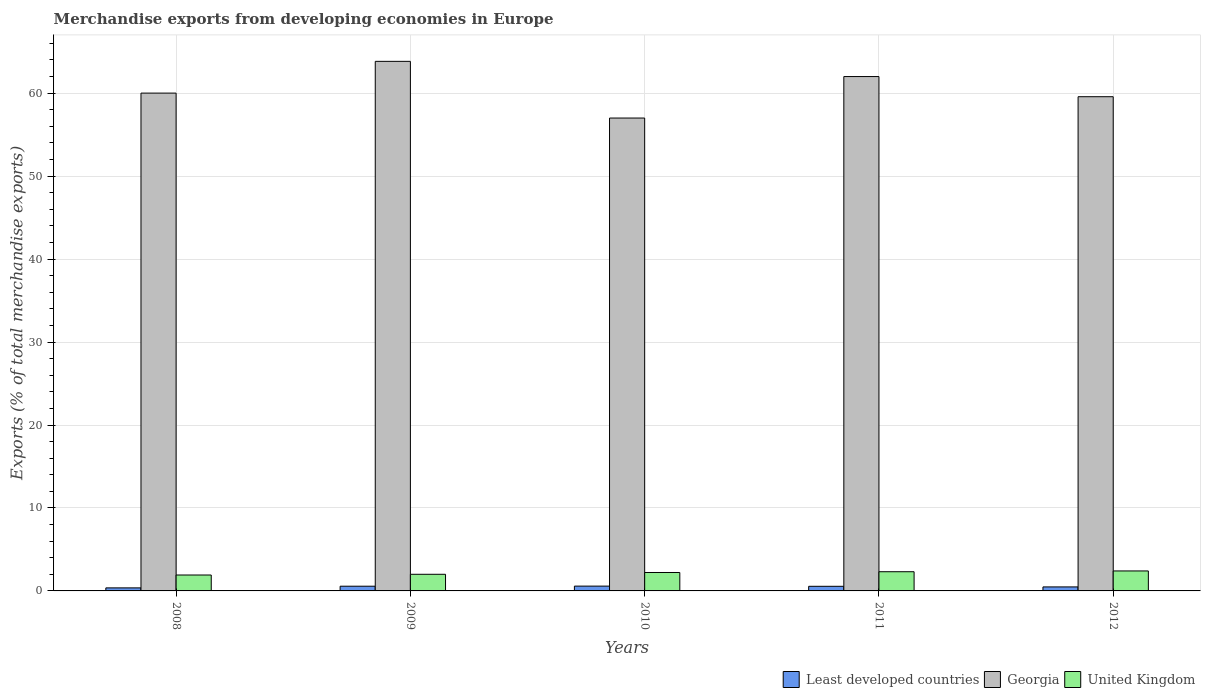Are the number of bars on each tick of the X-axis equal?
Ensure brevity in your answer.  Yes. How many bars are there on the 3rd tick from the left?
Offer a terse response. 3. What is the label of the 4th group of bars from the left?
Offer a terse response. 2011. What is the percentage of total merchandise exports in Georgia in 2012?
Your answer should be very brief. 59.57. Across all years, what is the maximum percentage of total merchandise exports in Georgia?
Your answer should be compact. 63.84. Across all years, what is the minimum percentage of total merchandise exports in Least developed countries?
Provide a short and direct response. 0.37. In which year was the percentage of total merchandise exports in Georgia maximum?
Provide a short and direct response. 2009. In which year was the percentage of total merchandise exports in Least developed countries minimum?
Offer a very short reply. 2008. What is the total percentage of total merchandise exports in Georgia in the graph?
Make the answer very short. 302.42. What is the difference between the percentage of total merchandise exports in Georgia in 2010 and that in 2011?
Your response must be concise. -5. What is the difference between the percentage of total merchandise exports in United Kingdom in 2008 and the percentage of total merchandise exports in Least developed countries in 2010?
Provide a short and direct response. 1.34. What is the average percentage of total merchandise exports in United Kingdom per year?
Offer a very short reply. 2.17. In the year 2008, what is the difference between the percentage of total merchandise exports in United Kingdom and percentage of total merchandise exports in Least developed countries?
Give a very brief answer. 1.55. What is the ratio of the percentage of total merchandise exports in Georgia in 2010 to that in 2012?
Give a very brief answer. 0.96. Is the percentage of total merchandise exports in Least developed countries in 2009 less than that in 2010?
Make the answer very short. Yes. What is the difference between the highest and the second highest percentage of total merchandise exports in United Kingdom?
Your response must be concise. 0.1. What is the difference between the highest and the lowest percentage of total merchandise exports in United Kingdom?
Your response must be concise. 0.49. What does the 1st bar from the left in 2009 represents?
Provide a succinct answer. Least developed countries. Are all the bars in the graph horizontal?
Offer a very short reply. No. What is the difference between two consecutive major ticks on the Y-axis?
Offer a very short reply. 10. Where does the legend appear in the graph?
Your response must be concise. Bottom right. How are the legend labels stacked?
Ensure brevity in your answer.  Horizontal. What is the title of the graph?
Provide a short and direct response. Merchandise exports from developing economies in Europe. What is the label or title of the Y-axis?
Your answer should be compact. Exports (% of total merchandise exports). What is the Exports (% of total merchandise exports) of Least developed countries in 2008?
Provide a succinct answer. 0.37. What is the Exports (% of total merchandise exports) in Georgia in 2008?
Your answer should be very brief. 60.01. What is the Exports (% of total merchandise exports) in United Kingdom in 2008?
Offer a very short reply. 1.92. What is the Exports (% of total merchandise exports) of Least developed countries in 2009?
Your answer should be compact. 0.57. What is the Exports (% of total merchandise exports) of Georgia in 2009?
Keep it short and to the point. 63.84. What is the Exports (% of total merchandise exports) in United Kingdom in 2009?
Your response must be concise. 2. What is the Exports (% of total merchandise exports) of Least developed countries in 2010?
Provide a succinct answer. 0.58. What is the Exports (% of total merchandise exports) of Georgia in 2010?
Ensure brevity in your answer.  57. What is the Exports (% of total merchandise exports) of United Kingdom in 2010?
Your answer should be very brief. 2.22. What is the Exports (% of total merchandise exports) of Least developed countries in 2011?
Ensure brevity in your answer.  0.56. What is the Exports (% of total merchandise exports) of Georgia in 2011?
Make the answer very short. 62. What is the Exports (% of total merchandise exports) in United Kingdom in 2011?
Offer a terse response. 2.31. What is the Exports (% of total merchandise exports) in Least developed countries in 2012?
Make the answer very short. 0.48. What is the Exports (% of total merchandise exports) in Georgia in 2012?
Your response must be concise. 59.57. What is the Exports (% of total merchandise exports) of United Kingdom in 2012?
Your answer should be compact. 2.41. Across all years, what is the maximum Exports (% of total merchandise exports) in Least developed countries?
Provide a succinct answer. 0.58. Across all years, what is the maximum Exports (% of total merchandise exports) in Georgia?
Your answer should be compact. 63.84. Across all years, what is the maximum Exports (% of total merchandise exports) of United Kingdom?
Provide a succinct answer. 2.41. Across all years, what is the minimum Exports (% of total merchandise exports) of Least developed countries?
Offer a terse response. 0.37. Across all years, what is the minimum Exports (% of total merchandise exports) of Georgia?
Ensure brevity in your answer.  57. Across all years, what is the minimum Exports (% of total merchandise exports) of United Kingdom?
Your answer should be compact. 1.92. What is the total Exports (% of total merchandise exports) in Least developed countries in the graph?
Offer a very short reply. 2.55. What is the total Exports (% of total merchandise exports) of Georgia in the graph?
Offer a very short reply. 302.42. What is the total Exports (% of total merchandise exports) in United Kingdom in the graph?
Your answer should be very brief. 10.87. What is the difference between the Exports (% of total merchandise exports) of Least developed countries in 2008 and that in 2009?
Your response must be concise. -0.2. What is the difference between the Exports (% of total merchandise exports) of Georgia in 2008 and that in 2009?
Make the answer very short. -3.83. What is the difference between the Exports (% of total merchandise exports) of United Kingdom in 2008 and that in 2009?
Give a very brief answer. -0.09. What is the difference between the Exports (% of total merchandise exports) in Least developed countries in 2008 and that in 2010?
Ensure brevity in your answer.  -0.21. What is the difference between the Exports (% of total merchandise exports) of Georgia in 2008 and that in 2010?
Provide a short and direct response. 3.01. What is the difference between the Exports (% of total merchandise exports) in United Kingdom in 2008 and that in 2010?
Your response must be concise. -0.3. What is the difference between the Exports (% of total merchandise exports) of Least developed countries in 2008 and that in 2011?
Make the answer very short. -0.19. What is the difference between the Exports (% of total merchandise exports) in Georgia in 2008 and that in 2011?
Make the answer very short. -1.99. What is the difference between the Exports (% of total merchandise exports) in United Kingdom in 2008 and that in 2011?
Keep it short and to the point. -0.39. What is the difference between the Exports (% of total merchandise exports) in Least developed countries in 2008 and that in 2012?
Provide a succinct answer. -0.12. What is the difference between the Exports (% of total merchandise exports) in Georgia in 2008 and that in 2012?
Offer a very short reply. 0.44. What is the difference between the Exports (% of total merchandise exports) in United Kingdom in 2008 and that in 2012?
Make the answer very short. -0.49. What is the difference between the Exports (% of total merchandise exports) in Least developed countries in 2009 and that in 2010?
Keep it short and to the point. -0.01. What is the difference between the Exports (% of total merchandise exports) of Georgia in 2009 and that in 2010?
Provide a short and direct response. 6.83. What is the difference between the Exports (% of total merchandise exports) in United Kingdom in 2009 and that in 2010?
Keep it short and to the point. -0.22. What is the difference between the Exports (% of total merchandise exports) in Least developed countries in 2009 and that in 2011?
Your answer should be very brief. 0.01. What is the difference between the Exports (% of total merchandise exports) of Georgia in 2009 and that in 2011?
Give a very brief answer. 1.83. What is the difference between the Exports (% of total merchandise exports) in United Kingdom in 2009 and that in 2011?
Ensure brevity in your answer.  -0.31. What is the difference between the Exports (% of total merchandise exports) in Least developed countries in 2009 and that in 2012?
Provide a short and direct response. 0.09. What is the difference between the Exports (% of total merchandise exports) in Georgia in 2009 and that in 2012?
Make the answer very short. 4.26. What is the difference between the Exports (% of total merchandise exports) of United Kingdom in 2009 and that in 2012?
Offer a very short reply. -0.4. What is the difference between the Exports (% of total merchandise exports) of Least developed countries in 2010 and that in 2011?
Your response must be concise. 0.02. What is the difference between the Exports (% of total merchandise exports) in Georgia in 2010 and that in 2011?
Give a very brief answer. -5. What is the difference between the Exports (% of total merchandise exports) in United Kingdom in 2010 and that in 2011?
Provide a short and direct response. -0.09. What is the difference between the Exports (% of total merchandise exports) in Least developed countries in 2010 and that in 2012?
Ensure brevity in your answer.  0.1. What is the difference between the Exports (% of total merchandise exports) of Georgia in 2010 and that in 2012?
Ensure brevity in your answer.  -2.57. What is the difference between the Exports (% of total merchandise exports) in United Kingdom in 2010 and that in 2012?
Offer a terse response. -0.19. What is the difference between the Exports (% of total merchandise exports) of Least developed countries in 2011 and that in 2012?
Keep it short and to the point. 0.07. What is the difference between the Exports (% of total merchandise exports) in Georgia in 2011 and that in 2012?
Keep it short and to the point. 2.43. What is the difference between the Exports (% of total merchandise exports) of United Kingdom in 2011 and that in 2012?
Give a very brief answer. -0.1. What is the difference between the Exports (% of total merchandise exports) in Least developed countries in 2008 and the Exports (% of total merchandise exports) in Georgia in 2009?
Give a very brief answer. -63.47. What is the difference between the Exports (% of total merchandise exports) of Least developed countries in 2008 and the Exports (% of total merchandise exports) of United Kingdom in 2009?
Keep it short and to the point. -1.64. What is the difference between the Exports (% of total merchandise exports) in Georgia in 2008 and the Exports (% of total merchandise exports) in United Kingdom in 2009?
Your answer should be compact. 58. What is the difference between the Exports (% of total merchandise exports) in Least developed countries in 2008 and the Exports (% of total merchandise exports) in Georgia in 2010?
Your answer should be compact. -56.64. What is the difference between the Exports (% of total merchandise exports) of Least developed countries in 2008 and the Exports (% of total merchandise exports) of United Kingdom in 2010?
Make the answer very short. -1.85. What is the difference between the Exports (% of total merchandise exports) in Georgia in 2008 and the Exports (% of total merchandise exports) in United Kingdom in 2010?
Make the answer very short. 57.79. What is the difference between the Exports (% of total merchandise exports) of Least developed countries in 2008 and the Exports (% of total merchandise exports) of Georgia in 2011?
Your answer should be compact. -61.64. What is the difference between the Exports (% of total merchandise exports) of Least developed countries in 2008 and the Exports (% of total merchandise exports) of United Kingdom in 2011?
Your answer should be compact. -1.95. What is the difference between the Exports (% of total merchandise exports) in Georgia in 2008 and the Exports (% of total merchandise exports) in United Kingdom in 2011?
Make the answer very short. 57.7. What is the difference between the Exports (% of total merchandise exports) of Least developed countries in 2008 and the Exports (% of total merchandise exports) of Georgia in 2012?
Ensure brevity in your answer.  -59.21. What is the difference between the Exports (% of total merchandise exports) in Least developed countries in 2008 and the Exports (% of total merchandise exports) in United Kingdom in 2012?
Give a very brief answer. -2.04. What is the difference between the Exports (% of total merchandise exports) of Georgia in 2008 and the Exports (% of total merchandise exports) of United Kingdom in 2012?
Provide a succinct answer. 57.6. What is the difference between the Exports (% of total merchandise exports) in Least developed countries in 2009 and the Exports (% of total merchandise exports) in Georgia in 2010?
Your answer should be very brief. -56.43. What is the difference between the Exports (% of total merchandise exports) of Least developed countries in 2009 and the Exports (% of total merchandise exports) of United Kingdom in 2010?
Give a very brief answer. -1.65. What is the difference between the Exports (% of total merchandise exports) in Georgia in 2009 and the Exports (% of total merchandise exports) in United Kingdom in 2010?
Your answer should be very brief. 61.61. What is the difference between the Exports (% of total merchandise exports) in Least developed countries in 2009 and the Exports (% of total merchandise exports) in Georgia in 2011?
Provide a succinct answer. -61.43. What is the difference between the Exports (% of total merchandise exports) in Least developed countries in 2009 and the Exports (% of total merchandise exports) in United Kingdom in 2011?
Keep it short and to the point. -1.74. What is the difference between the Exports (% of total merchandise exports) in Georgia in 2009 and the Exports (% of total merchandise exports) in United Kingdom in 2011?
Ensure brevity in your answer.  61.52. What is the difference between the Exports (% of total merchandise exports) of Least developed countries in 2009 and the Exports (% of total merchandise exports) of Georgia in 2012?
Offer a terse response. -59. What is the difference between the Exports (% of total merchandise exports) in Least developed countries in 2009 and the Exports (% of total merchandise exports) in United Kingdom in 2012?
Give a very brief answer. -1.84. What is the difference between the Exports (% of total merchandise exports) in Georgia in 2009 and the Exports (% of total merchandise exports) in United Kingdom in 2012?
Your answer should be compact. 61.43. What is the difference between the Exports (% of total merchandise exports) in Least developed countries in 2010 and the Exports (% of total merchandise exports) in Georgia in 2011?
Keep it short and to the point. -61.42. What is the difference between the Exports (% of total merchandise exports) in Least developed countries in 2010 and the Exports (% of total merchandise exports) in United Kingdom in 2011?
Make the answer very short. -1.73. What is the difference between the Exports (% of total merchandise exports) in Georgia in 2010 and the Exports (% of total merchandise exports) in United Kingdom in 2011?
Keep it short and to the point. 54.69. What is the difference between the Exports (% of total merchandise exports) of Least developed countries in 2010 and the Exports (% of total merchandise exports) of Georgia in 2012?
Offer a terse response. -58.99. What is the difference between the Exports (% of total merchandise exports) in Least developed countries in 2010 and the Exports (% of total merchandise exports) in United Kingdom in 2012?
Provide a short and direct response. -1.83. What is the difference between the Exports (% of total merchandise exports) in Georgia in 2010 and the Exports (% of total merchandise exports) in United Kingdom in 2012?
Give a very brief answer. 54.59. What is the difference between the Exports (% of total merchandise exports) of Least developed countries in 2011 and the Exports (% of total merchandise exports) of Georgia in 2012?
Keep it short and to the point. -59.02. What is the difference between the Exports (% of total merchandise exports) in Least developed countries in 2011 and the Exports (% of total merchandise exports) in United Kingdom in 2012?
Give a very brief answer. -1.85. What is the difference between the Exports (% of total merchandise exports) in Georgia in 2011 and the Exports (% of total merchandise exports) in United Kingdom in 2012?
Keep it short and to the point. 59.6. What is the average Exports (% of total merchandise exports) of Least developed countries per year?
Keep it short and to the point. 0.51. What is the average Exports (% of total merchandise exports) in Georgia per year?
Ensure brevity in your answer.  60.48. What is the average Exports (% of total merchandise exports) of United Kingdom per year?
Offer a terse response. 2.17. In the year 2008, what is the difference between the Exports (% of total merchandise exports) in Least developed countries and Exports (% of total merchandise exports) in Georgia?
Give a very brief answer. -59.64. In the year 2008, what is the difference between the Exports (% of total merchandise exports) in Least developed countries and Exports (% of total merchandise exports) in United Kingdom?
Keep it short and to the point. -1.55. In the year 2008, what is the difference between the Exports (% of total merchandise exports) of Georgia and Exports (% of total merchandise exports) of United Kingdom?
Give a very brief answer. 58.09. In the year 2009, what is the difference between the Exports (% of total merchandise exports) in Least developed countries and Exports (% of total merchandise exports) in Georgia?
Make the answer very short. -63.27. In the year 2009, what is the difference between the Exports (% of total merchandise exports) in Least developed countries and Exports (% of total merchandise exports) in United Kingdom?
Make the answer very short. -1.44. In the year 2009, what is the difference between the Exports (% of total merchandise exports) in Georgia and Exports (% of total merchandise exports) in United Kingdom?
Give a very brief answer. 61.83. In the year 2010, what is the difference between the Exports (% of total merchandise exports) in Least developed countries and Exports (% of total merchandise exports) in Georgia?
Provide a succinct answer. -56.42. In the year 2010, what is the difference between the Exports (% of total merchandise exports) in Least developed countries and Exports (% of total merchandise exports) in United Kingdom?
Ensure brevity in your answer.  -1.64. In the year 2010, what is the difference between the Exports (% of total merchandise exports) in Georgia and Exports (% of total merchandise exports) in United Kingdom?
Keep it short and to the point. 54.78. In the year 2011, what is the difference between the Exports (% of total merchandise exports) of Least developed countries and Exports (% of total merchandise exports) of Georgia?
Ensure brevity in your answer.  -61.45. In the year 2011, what is the difference between the Exports (% of total merchandise exports) of Least developed countries and Exports (% of total merchandise exports) of United Kingdom?
Ensure brevity in your answer.  -1.76. In the year 2011, what is the difference between the Exports (% of total merchandise exports) in Georgia and Exports (% of total merchandise exports) in United Kingdom?
Offer a very short reply. 59.69. In the year 2012, what is the difference between the Exports (% of total merchandise exports) of Least developed countries and Exports (% of total merchandise exports) of Georgia?
Make the answer very short. -59.09. In the year 2012, what is the difference between the Exports (% of total merchandise exports) in Least developed countries and Exports (% of total merchandise exports) in United Kingdom?
Your answer should be compact. -1.92. In the year 2012, what is the difference between the Exports (% of total merchandise exports) in Georgia and Exports (% of total merchandise exports) in United Kingdom?
Your answer should be very brief. 57.16. What is the ratio of the Exports (% of total merchandise exports) of Least developed countries in 2008 to that in 2009?
Ensure brevity in your answer.  0.64. What is the ratio of the Exports (% of total merchandise exports) of Georgia in 2008 to that in 2009?
Offer a terse response. 0.94. What is the ratio of the Exports (% of total merchandise exports) in United Kingdom in 2008 to that in 2009?
Ensure brevity in your answer.  0.96. What is the ratio of the Exports (% of total merchandise exports) of Least developed countries in 2008 to that in 2010?
Give a very brief answer. 0.63. What is the ratio of the Exports (% of total merchandise exports) of Georgia in 2008 to that in 2010?
Offer a terse response. 1.05. What is the ratio of the Exports (% of total merchandise exports) of United Kingdom in 2008 to that in 2010?
Provide a short and direct response. 0.86. What is the ratio of the Exports (% of total merchandise exports) in Least developed countries in 2008 to that in 2011?
Your answer should be compact. 0.66. What is the ratio of the Exports (% of total merchandise exports) of Georgia in 2008 to that in 2011?
Provide a short and direct response. 0.97. What is the ratio of the Exports (% of total merchandise exports) of United Kingdom in 2008 to that in 2011?
Your response must be concise. 0.83. What is the ratio of the Exports (% of total merchandise exports) of Least developed countries in 2008 to that in 2012?
Offer a very short reply. 0.76. What is the ratio of the Exports (% of total merchandise exports) in Georgia in 2008 to that in 2012?
Ensure brevity in your answer.  1.01. What is the ratio of the Exports (% of total merchandise exports) of United Kingdom in 2008 to that in 2012?
Keep it short and to the point. 0.8. What is the ratio of the Exports (% of total merchandise exports) in Least developed countries in 2009 to that in 2010?
Offer a very short reply. 0.98. What is the ratio of the Exports (% of total merchandise exports) in Georgia in 2009 to that in 2010?
Provide a succinct answer. 1.12. What is the ratio of the Exports (% of total merchandise exports) of United Kingdom in 2009 to that in 2010?
Provide a short and direct response. 0.9. What is the ratio of the Exports (% of total merchandise exports) in Least developed countries in 2009 to that in 2011?
Give a very brief answer. 1.02. What is the ratio of the Exports (% of total merchandise exports) in Georgia in 2009 to that in 2011?
Provide a short and direct response. 1.03. What is the ratio of the Exports (% of total merchandise exports) of United Kingdom in 2009 to that in 2011?
Ensure brevity in your answer.  0.87. What is the ratio of the Exports (% of total merchandise exports) in Least developed countries in 2009 to that in 2012?
Your answer should be very brief. 1.18. What is the ratio of the Exports (% of total merchandise exports) in Georgia in 2009 to that in 2012?
Ensure brevity in your answer.  1.07. What is the ratio of the Exports (% of total merchandise exports) in United Kingdom in 2009 to that in 2012?
Give a very brief answer. 0.83. What is the ratio of the Exports (% of total merchandise exports) of Least developed countries in 2010 to that in 2011?
Offer a terse response. 1.04. What is the ratio of the Exports (% of total merchandise exports) in Georgia in 2010 to that in 2011?
Make the answer very short. 0.92. What is the ratio of the Exports (% of total merchandise exports) of United Kingdom in 2010 to that in 2011?
Offer a terse response. 0.96. What is the ratio of the Exports (% of total merchandise exports) in Least developed countries in 2010 to that in 2012?
Ensure brevity in your answer.  1.2. What is the ratio of the Exports (% of total merchandise exports) in Georgia in 2010 to that in 2012?
Keep it short and to the point. 0.96. What is the ratio of the Exports (% of total merchandise exports) of United Kingdom in 2010 to that in 2012?
Give a very brief answer. 0.92. What is the ratio of the Exports (% of total merchandise exports) in Least developed countries in 2011 to that in 2012?
Your answer should be very brief. 1.15. What is the ratio of the Exports (% of total merchandise exports) of Georgia in 2011 to that in 2012?
Your answer should be very brief. 1.04. What is the ratio of the Exports (% of total merchandise exports) in United Kingdom in 2011 to that in 2012?
Give a very brief answer. 0.96. What is the difference between the highest and the second highest Exports (% of total merchandise exports) in Least developed countries?
Offer a very short reply. 0.01. What is the difference between the highest and the second highest Exports (% of total merchandise exports) of Georgia?
Keep it short and to the point. 1.83. What is the difference between the highest and the second highest Exports (% of total merchandise exports) in United Kingdom?
Make the answer very short. 0.1. What is the difference between the highest and the lowest Exports (% of total merchandise exports) in Least developed countries?
Give a very brief answer. 0.21. What is the difference between the highest and the lowest Exports (% of total merchandise exports) of Georgia?
Your answer should be compact. 6.83. What is the difference between the highest and the lowest Exports (% of total merchandise exports) in United Kingdom?
Provide a succinct answer. 0.49. 